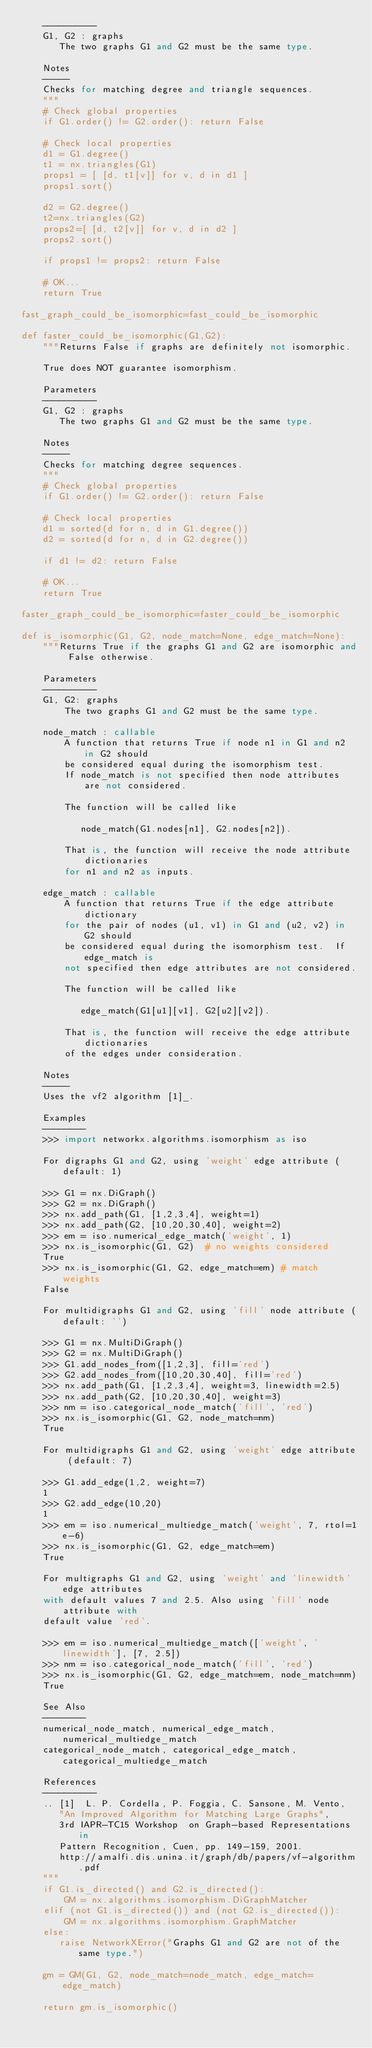<code> <loc_0><loc_0><loc_500><loc_500><_Python_>    ----------
    G1, G2 : graphs
       The two graphs G1 and G2 must be the same type.

    Notes
    -----
    Checks for matching degree and triangle sequences.
    """
    # Check global properties
    if G1.order() != G2.order(): return False

    # Check local properties
    d1 = G1.degree()
    t1 = nx.triangles(G1)
    props1 = [ [d, t1[v]] for v, d in d1 ]
    props1.sort()

    d2 = G2.degree()
    t2=nx.triangles(G2)
    props2=[ [d, t2[v]] for v, d in d2 ]
    props2.sort()

    if props1 != props2: return False

    # OK...
    return True

fast_graph_could_be_isomorphic=fast_could_be_isomorphic

def faster_could_be_isomorphic(G1,G2):
    """Returns False if graphs are definitely not isomorphic.

    True does NOT guarantee isomorphism.

    Parameters
    ----------
    G1, G2 : graphs
       The two graphs G1 and G2 must be the same type.

    Notes
    -----
    Checks for matching degree sequences.
    """
    # Check global properties
    if G1.order() != G2.order(): return False

    # Check local properties
    d1 = sorted(d for n, d in G1.degree())
    d2 = sorted(d for n, d in G2.degree())

    if d1 != d2: return False

    # OK...
    return True

faster_graph_could_be_isomorphic=faster_could_be_isomorphic

def is_isomorphic(G1, G2, node_match=None, edge_match=None):
    """Returns True if the graphs G1 and G2 are isomorphic and False otherwise.

    Parameters
    ----------
    G1, G2: graphs
        The two graphs G1 and G2 must be the same type.

    node_match : callable
        A function that returns True if node n1 in G1 and n2 in G2 should
        be considered equal during the isomorphism test.
        If node_match is not specified then node attributes are not considered.

        The function will be called like

           node_match(G1.nodes[n1], G2.nodes[n2]).

        That is, the function will receive the node attribute dictionaries
        for n1 and n2 as inputs.

    edge_match : callable
        A function that returns True if the edge attribute dictionary
        for the pair of nodes (u1, v1) in G1 and (u2, v2) in G2 should
        be considered equal during the isomorphism test.  If edge_match is
        not specified then edge attributes are not considered.

        The function will be called like

           edge_match(G1[u1][v1], G2[u2][v2]).

        That is, the function will receive the edge attribute dictionaries
        of the edges under consideration.

    Notes
    -----
    Uses the vf2 algorithm [1]_.

    Examples
    --------
    >>> import networkx.algorithms.isomorphism as iso

    For digraphs G1 and G2, using 'weight' edge attribute (default: 1)

    >>> G1 = nx.DiGraph()
    >>> G2 = nx.DiGraph()
    >>> nx.add_path(G1, [1,2,3,4], weight=1)
    >>> nx.add_path(G2, [10,20,30,40], weight=2)
    >>> em = iso.numerical_edge_match('weight', 1)
    >>> nx.is_isomorphic(G1, G2)  # no weights considered
    True
    >>> nx.is_isomorphic(G1, G2, edge_match=em) # match weights
    False

    For multidigraphs G1 and G2, using 'fill' node attribute (default: '')

    >>> G1 = nx.MultiDiGraph()
    >>> G2 = nx.MultiDiGraph()
    >>> G1.add_nodes_from([1,2,3], fill='red')
    >>> G2.add_nodes_from([10,20,30,40], fill='red')
    >>> nx.add_path(G1, [1,2,3,4], weight=3, linewidth=2.5)
    >>> nx.add_path(G2, [10,20,30,40], weight=3)
    >>> nm = iso.categorical_node_match('fill', 'red')
    >>> nx.is_isomorphic(G1, G2, node_match=nm)
    True

    For multidigraphs G1 and G2, using 'weight' edge attribute (default: 7)

    >>> G1.add_edge(1,2, weight=7)
    1
    >>> G2.add_edge(10,20)
    1
    >>> em = iso.numerical_multiedge_match('weight', 7, rtol=1e-6)
    >>> nx.is_isomorphic(G1, G2, edge_match=em)
    True

    For multigraphs G1 and G2, using 'weight' and 'linewidth' edge attributes
    with default values 7 and 2.5. Also using 'fill' node attribute with
    default value 'red'.

    >>> em = iso.numerical_multiedge_match(['weight', 'linewidth'], [7, 2.5])
    >>> nm = iso.categorical_node_match('fill', 'red')
    >>> nx.is_isomorphic(G1, G2, edge_match=em, node_match=nm)
    True

    See Also
    --------
    numerical_node_match, numerical_edge_match, numerical_multiedge_match
    categorical_node_match, categorical_edge_match, categorical_multiedge_match

    References
    ----------
    .. [1]  L. P. Cordella, P. Foggia, C. Sansone, M. Vento,
       "An Improved Algorithm for Matching Large Graphs",
       3rd IAPR-TC15 Workshop  on Graph-based Representations in
       Pattern Recognition, Cuen, pp. 149-159, 2001.
       http://amalfi.dis.unina.it/graph/db/papers/vf-algorithm.pdf
    """
    if G1.is_directed() and G2.is_directed():
        GM = nx.algorithms.isomorphism.DiGraphMatcher
    elif (not G1.is_directed()) and (not G2.is_directed()):
        GM = nx.algorithms.isomorphism.GraphMatcher
    else:
       raise NetworkXError("Graphs G1 and G2 are not of the same type.")

    gm = GM(G1, G2, node_match=node_match, edge_match=edge_match)

    return gm.is_isomorphic()
</code> 